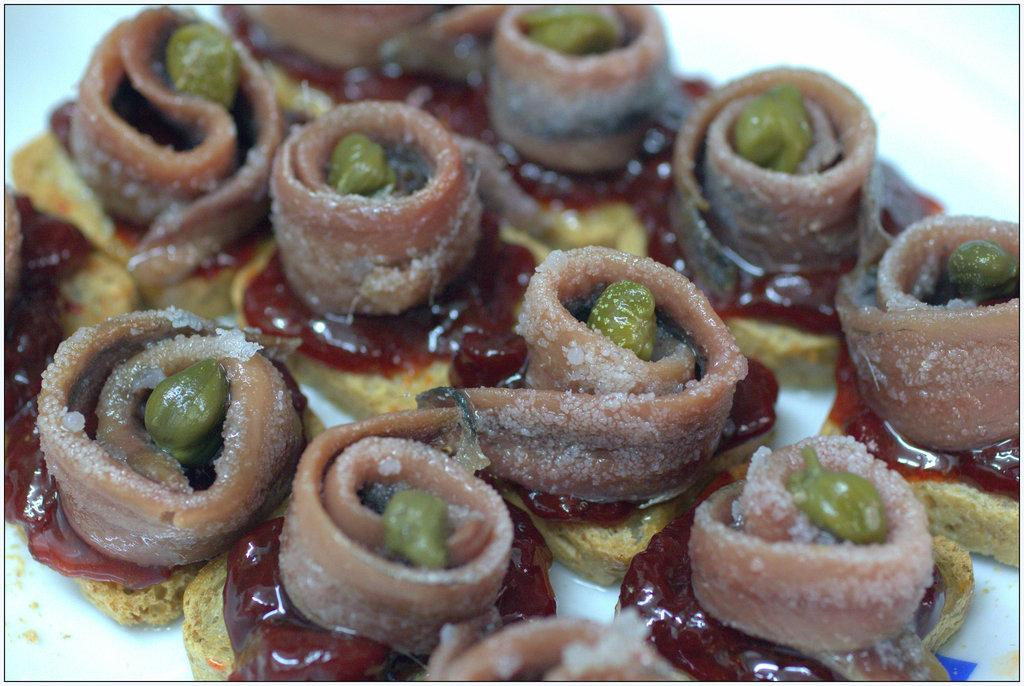What is present on the plate in the image? There are food items on the plate in the image. What type of food does the person in the image hate? There is no person present in the image, and therefore no indication of any food preferences or dislikes. Is there a banana visible on the plate in the image? The provided facts do not mention any specific food items, so it cannot be determined if a banana is present or not. 